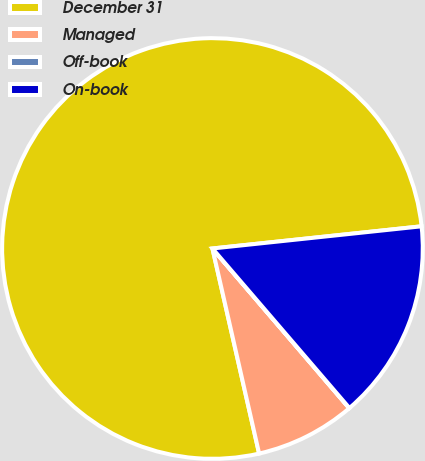<chart> <loc_0><loc_0><loc_500><loc_500><pie_chart><fcel>December 31<fcel>Managed<fcel>Off-book<fcel>On-book<nl><fcel>76.88%<fcel>7.71%<fcel>0.02%<fcel>15.39%<nl></chart> 